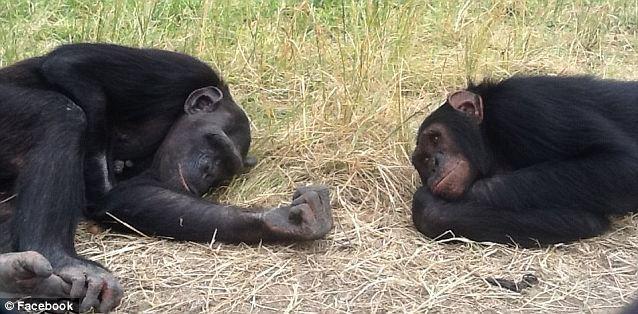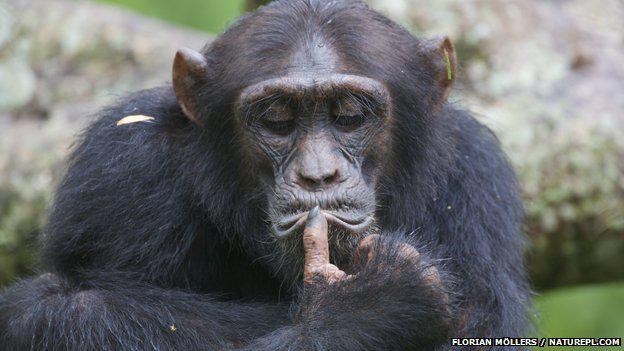The first image is the image on the left, the second image is the image on the right. For the images displayed, is the sentence "One animal is sleeping on another in the image on the left." factually correct? Answer yes or no. No. The first image is the image on the left, the second image is the image on the right. For the images displayed, is the sentence "An image shows a baby chimp sleeping on top of an adult chimp." factually correct? Answer yes or no. No. 